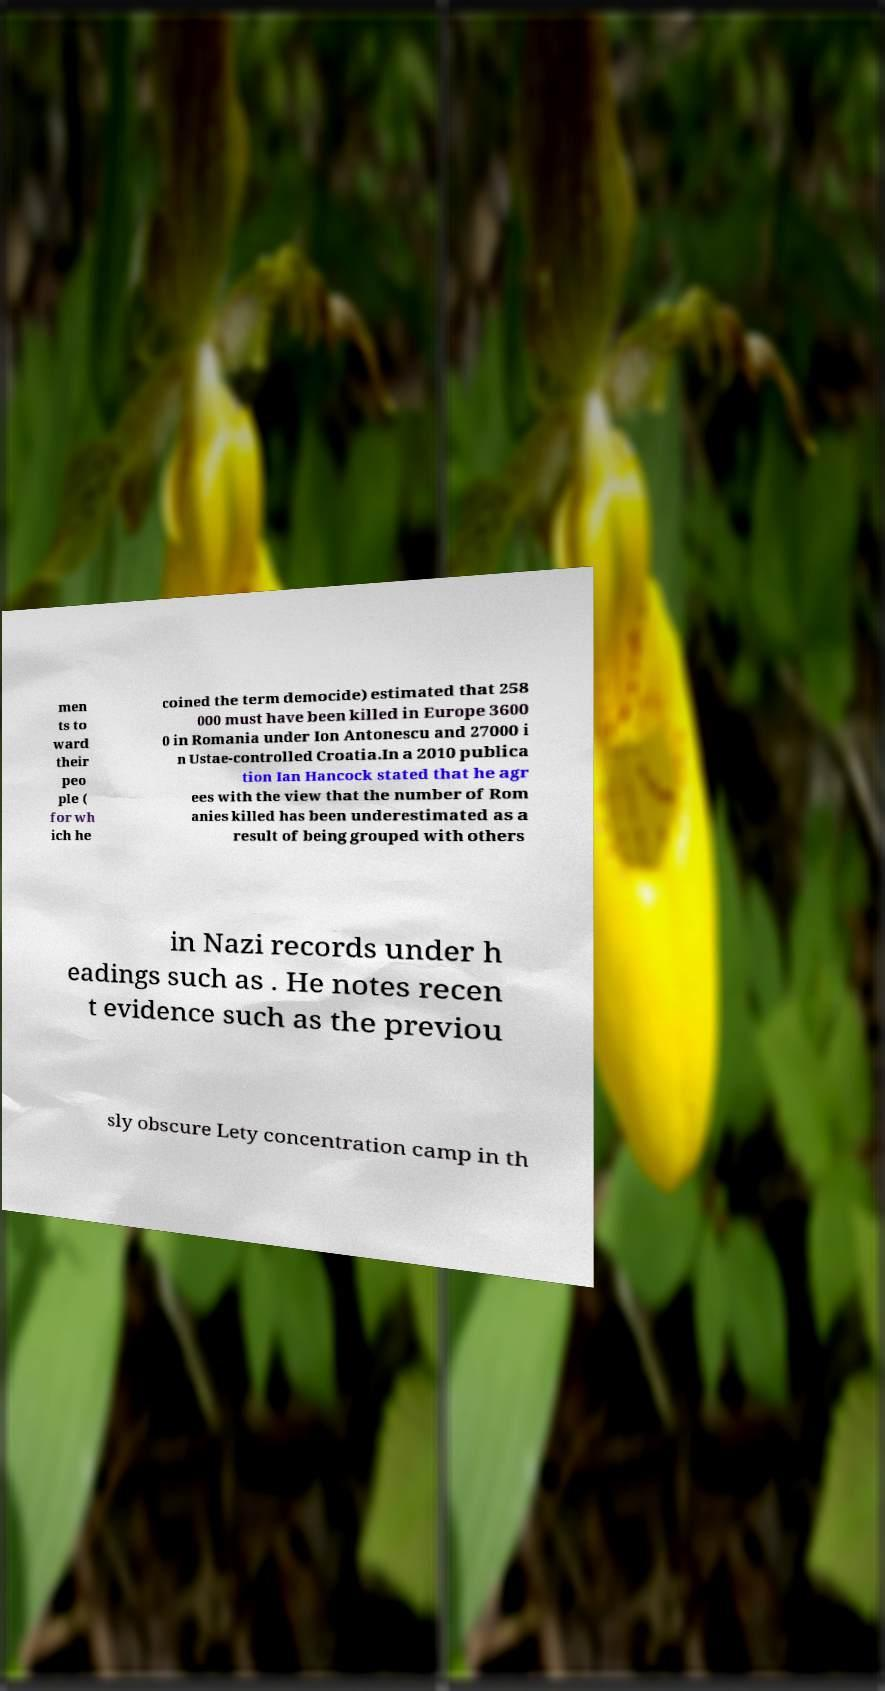For documentation purposes, I need the text within this image transcribed. Could you provide that? men ts to ward their peo ple ( for wh ich he coined the term democide) estimated that 258 000 must have been killed in Europe 3600 0 in Romania under Ion Antonescu and 27000 i n Ustae-controlled Croatia.In a 2010 publica tion Ian Hancock stated that he agr ees with the view that the number of Rom anies killed has been underestimated as a result of being grouped with others in Nazi records under h eadings such as . He notes recen t evidence such as the previou sly obscure Lety concentration camp in th 